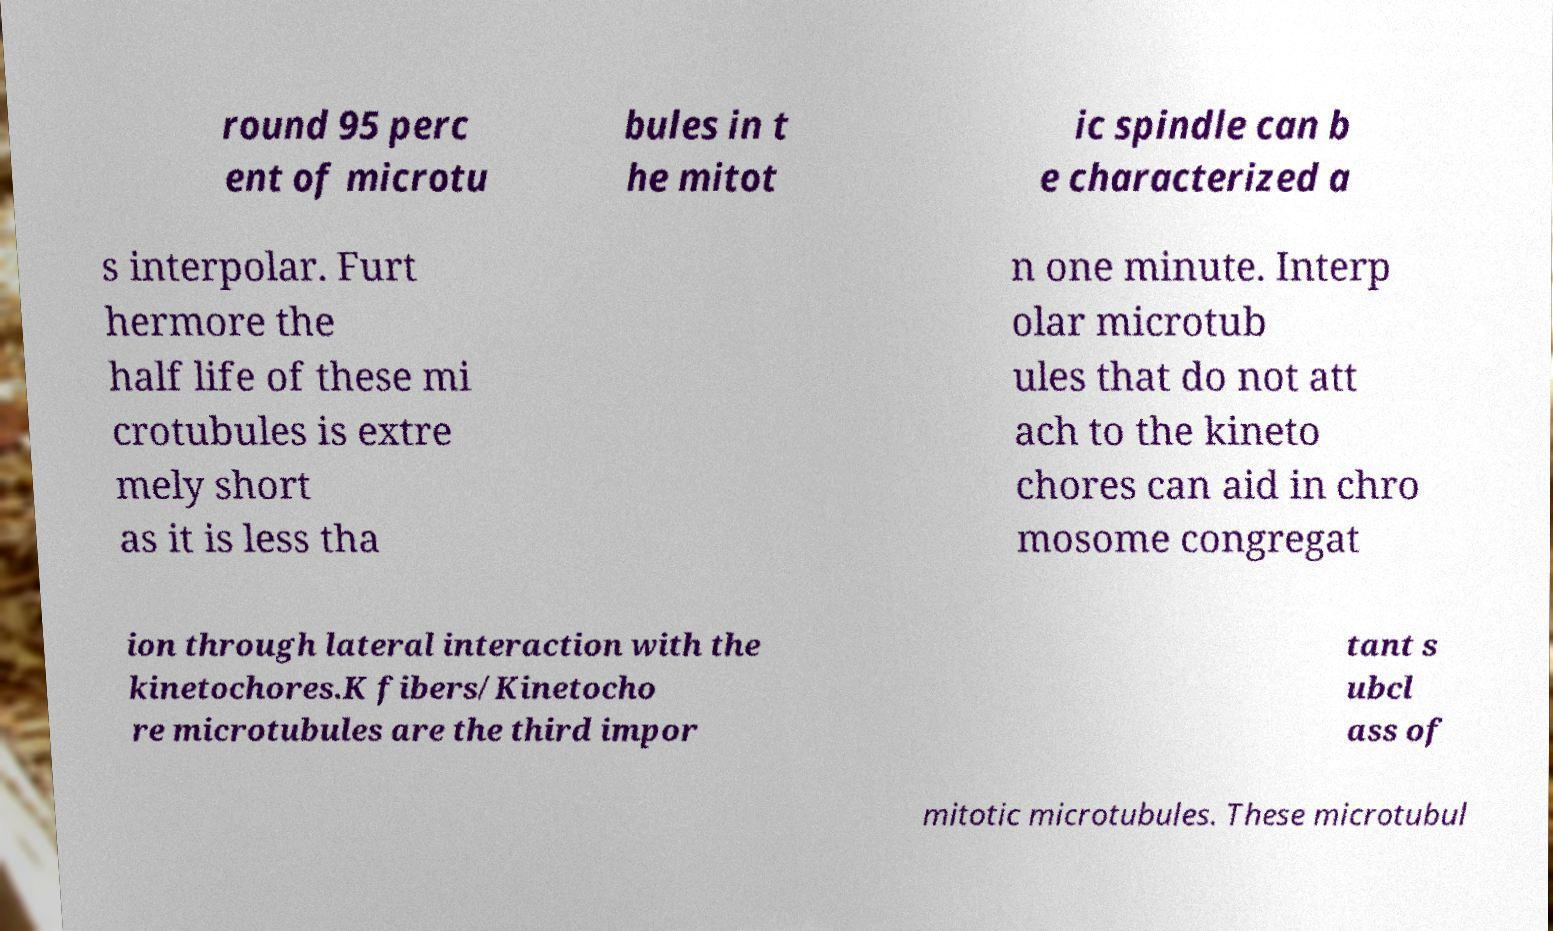I need the written content from this picture converted into text. Can you do that? round 95 perc ent of microtu bules in t he mitot ic spindle can b e characterized a s interpolar. Furt hermore the half life of these mi crotubules is extre mely short as it is less tha n one minute. Interp olar microtub ules that do not att ach to the kineto chores can aid in chro mosome congregat ion through lateral interaction with the kinetochores.K fibers/Kinetocho re microtubules are the third impor tant s ubcl ass of mitotic microtubules. These microtubul 